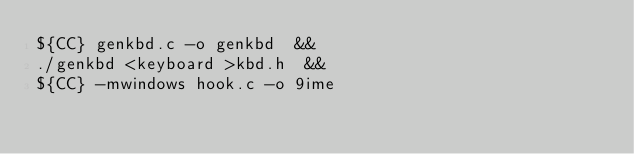Convert code to text. <code><loc_0><loc_0><loc_500><loc_500><_Bash_>${CC} genkbd.c -o genkbd  &&
./genkbd <keyboard >kbd.h  &&
${CC} -mwindows hook.c -o 9ime
</code> 